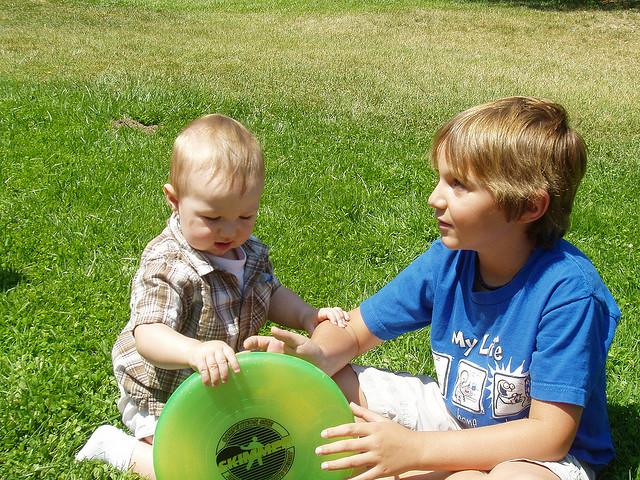What is the boy sitting next to?
Keep it brief. Frisbee. Are these two brothers?
Keep it brief. Yes. Does the baby have on socks?
Keep it brief. Yes. What toy do they have?
Write a very short answer. Frisbee. What color is the Frisbee?
Keep it brief. Green. 